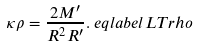<formula> <loc_0><loc_0><loc_500><loc_500>\kappa \rho & = \frac { 2 M ^ { \prime } } { R ^ { 2 } R ^ { \prime } } . \ e q l a b e l { L T r h o }</formula> 